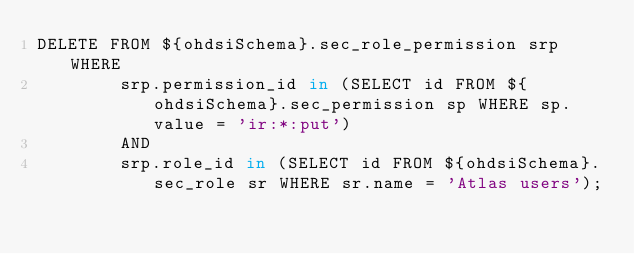Convert code to text. <code><loc_0><loc_0><loc_500><loc_500><_SQL_>DELETE FROM ${ohdsiSchema}.sec_role_permission srp WHERE
        srp.permission_id in (SELECT id FROM ${ohdsiSchema}.sec_permission sp WHERE sp.value = 'ir:*:put')
        AND
        srp.role_id in (SELECT id FROM ${ohdsiSchema}.sec_role sr WHERE sr.name = 'Atlas users');</code> 